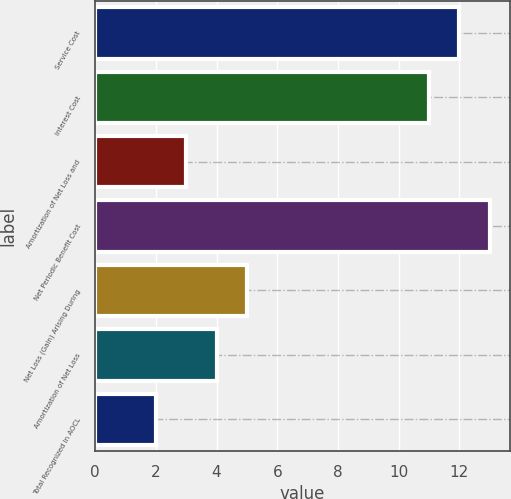<chart> <loc_0><loc_0><loc_500><loc_500><bar_chart><fcel>Service Cost<fcel>Interest Cost<fcel>Amortization of Net Loss and<fcel>Net Periodic Benefit Cost<fcel>Net Loss (Gain) Arising During<fcel>Amortization of Net Loss<fcel>Total Recognized in AOCL<nl><fcel>12<fcel>11<fcel>3<fcel>13<fcel>5<fcel>4<fcel>2<nl></chart> 